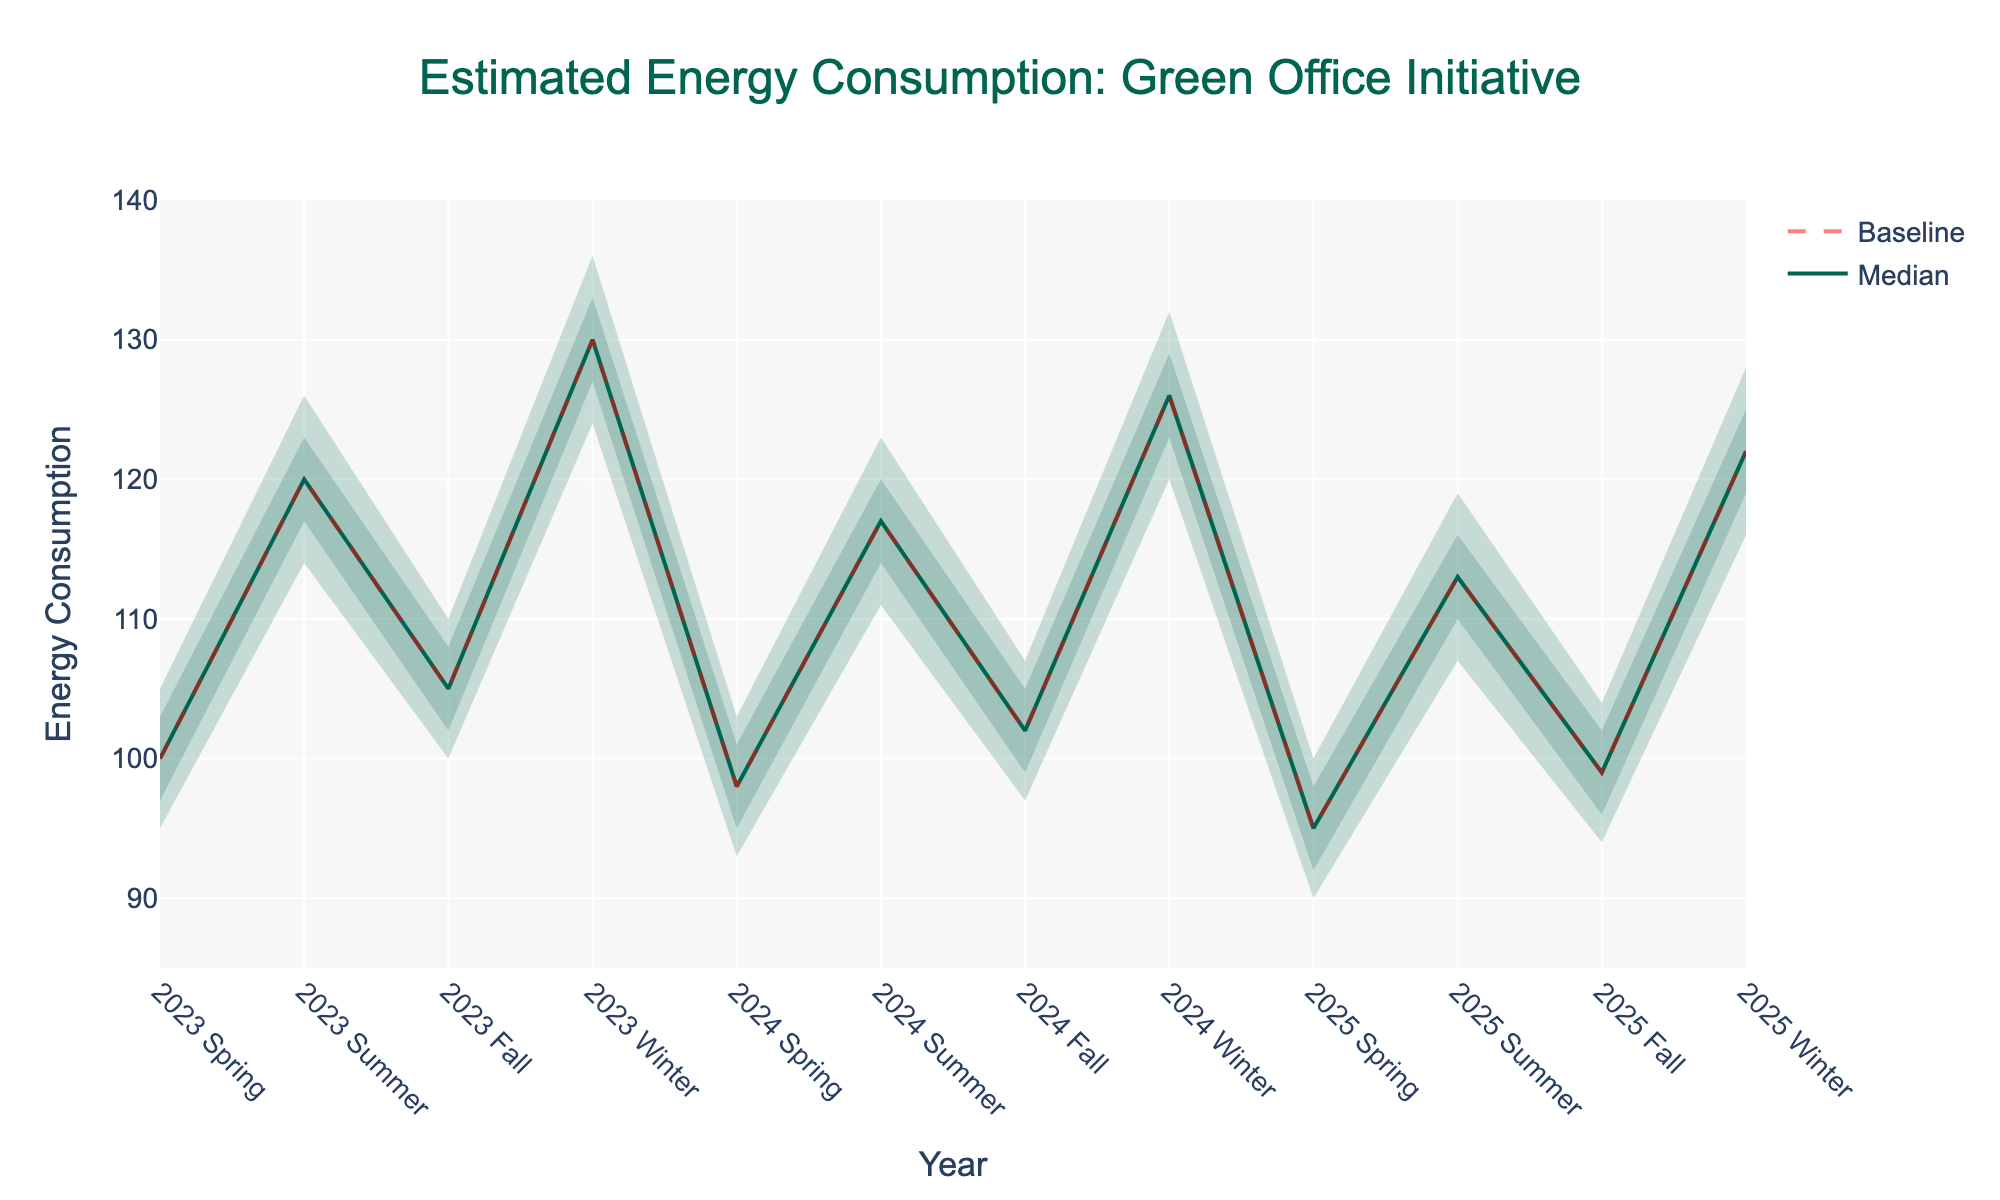What is the title of the chart? The title is at the top center of the chart. It reads "Estimated Energy Consumption: Green Office Initiative".
Answer: Estimated Energy Consumption: Green Office Initiative Which season in 2024 has the lowest median energy consumption? Look at the median lines for each season in 2024, and identify which one is the lowest.
Answer: Spring How does the baseline energy consumption in winter 2023 compare to winter 2024? Locate the baseline values for winter 2023 and winter 2024 and compare them. For winter 2023, the baseline is 130, and for winter 2024, it is 126.
Answer: Winter 2023 is higher What is the difference between the high 90% and low 10% estimates for energy consumption in Summer 2025? Find the high 90% and low 10% values for Summer 2025. High 90% is 119, and Low 10% is 107. Subtract the low from the high.
Answer: 12 Does the median energy consumption generally increase or decrease from 2023 to 2025? Examine the trend of the median lines from 2023 to 2025 across all seasons to identify if the general trend is upward or downward.
Answer: Decrease Which season shows the greatest reduction in median energy consumption from 2023 to 2025? Compare the median values for each season from 2023 and 2025. Calculate the difference and identify the greatest reduction. The greatest reduction is in Winter, from 130 in 2023 to 122 in 2025, which is 8 units.
Answer: Winter Are there any seasons where the 75% confidence interval is not symmetrical around the median? Look at the lines for the 25% and 75% estimates and check their relative positions around the median line for all seasons.
Answer: No What is the median energy consumption in Fall 2024 and Fall 2025, and how do they compare? Identify the median values for Fall 2024 and Fall 2025. Fall 2024 is 102, and Fall 2025 is 99.
Answer: Fall 2025 is lower In which season of 2023 is the energy consumption most variable? To measure variability, compare the range between the high 90% and low 10% estimates across all seasons in 2023. The greatest range lies in Winter, from 124 to 136, which is 12 units.
Answer: Winter What is the baseline energy consumption in Spring 2024? Locate the baseline value on the graph for Spring 2024.
Answer: 98 